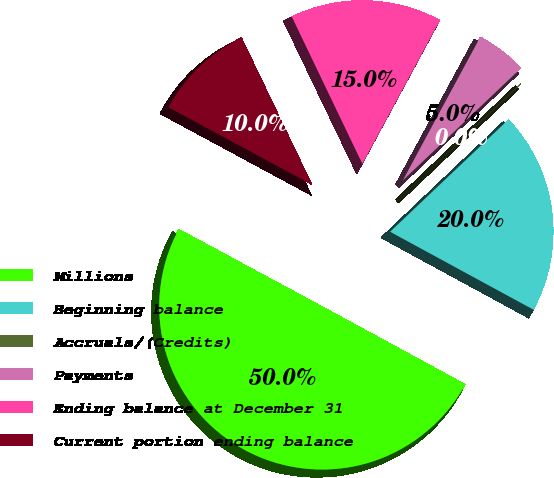<chart> <loc_0><loc_0><loc_500><loc_500><pie_chart><fcel>Millions<fcel>Beginning balance<fcel>Accruals/(Credits)<fcel>Payments<fcel>Ending balance at December 31<fcel>Current portion ending balance<nl><fcel>49.95%<fcel>20.0%<fcel>0.02%<fcel>5.02%<fcel>15.0%<fcel>10.01%<nl></chart> 